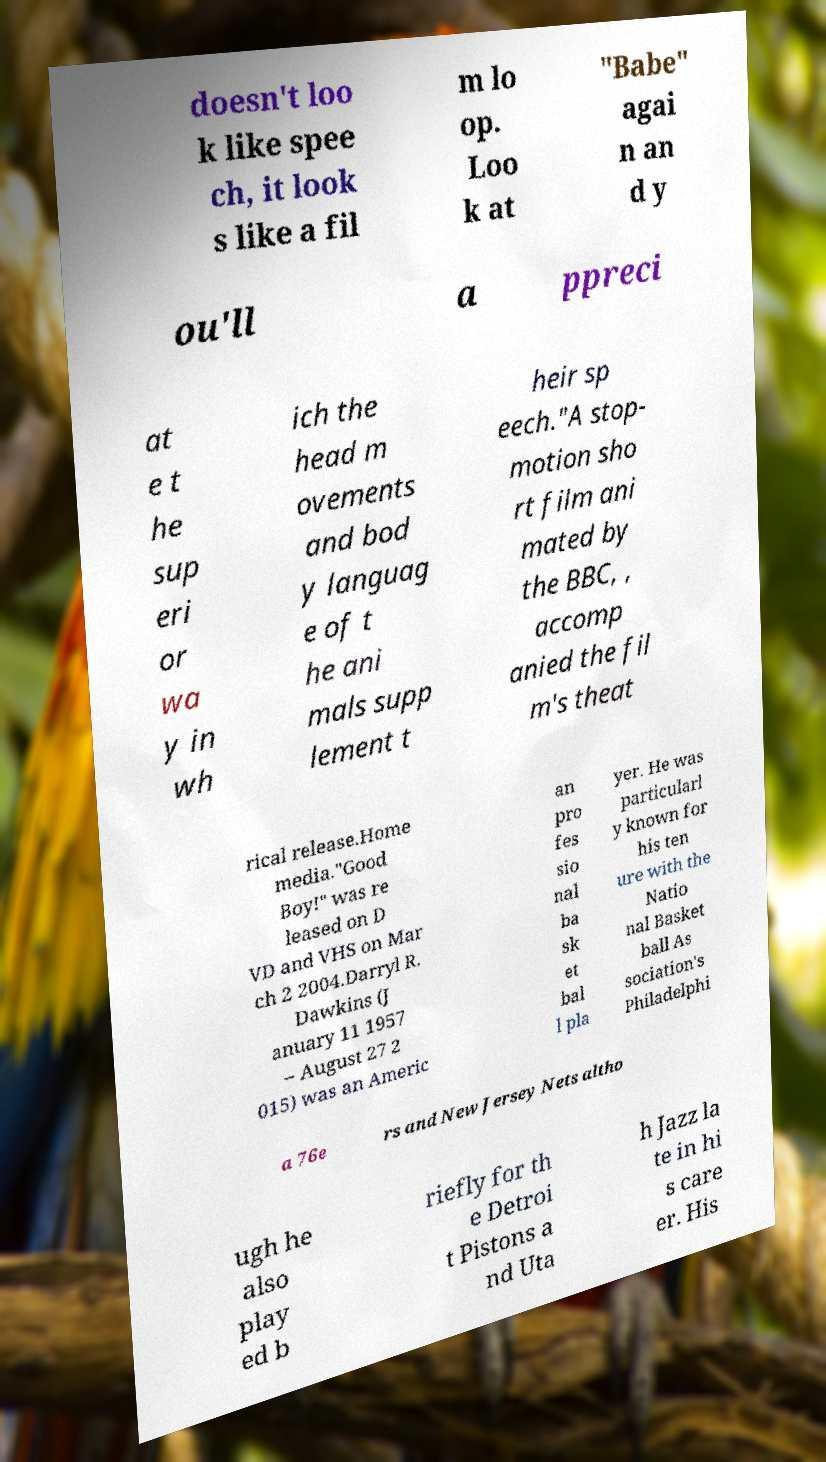What messages or text are displayed in this image? I need them in a readable, typed format. doesn't loo k like spee ch, it look s like a fil m lo op. Loo k at "Babe" agai n an d y ou'll a ppreci at e t he sup eri or wa y in wh ich the head m ovements and bod y languag e of t he ani mals supp lement t heir sp eech."A stop- motion sho rt film ani mated by the BBC, , accomp anied the fil m's theat rical release.Home media."Good Boy!" was re leased on D VD and VHS on Mar ch 2 2004.Darryl R. Dawkins (J anuary 11 1957 – August 27 2 015) was an Americ an pro fes sio nal ba sk et bal l pla yer. He was particularl y known for his ten ure with the Natio nal Basket ball As sociation's Philadelphi a 76e rs and New Jersey Nets altho ugh he also play ed b riefly for th e Detroi t Pistons a nd Uta h Jazz la te in hi s care er. His 